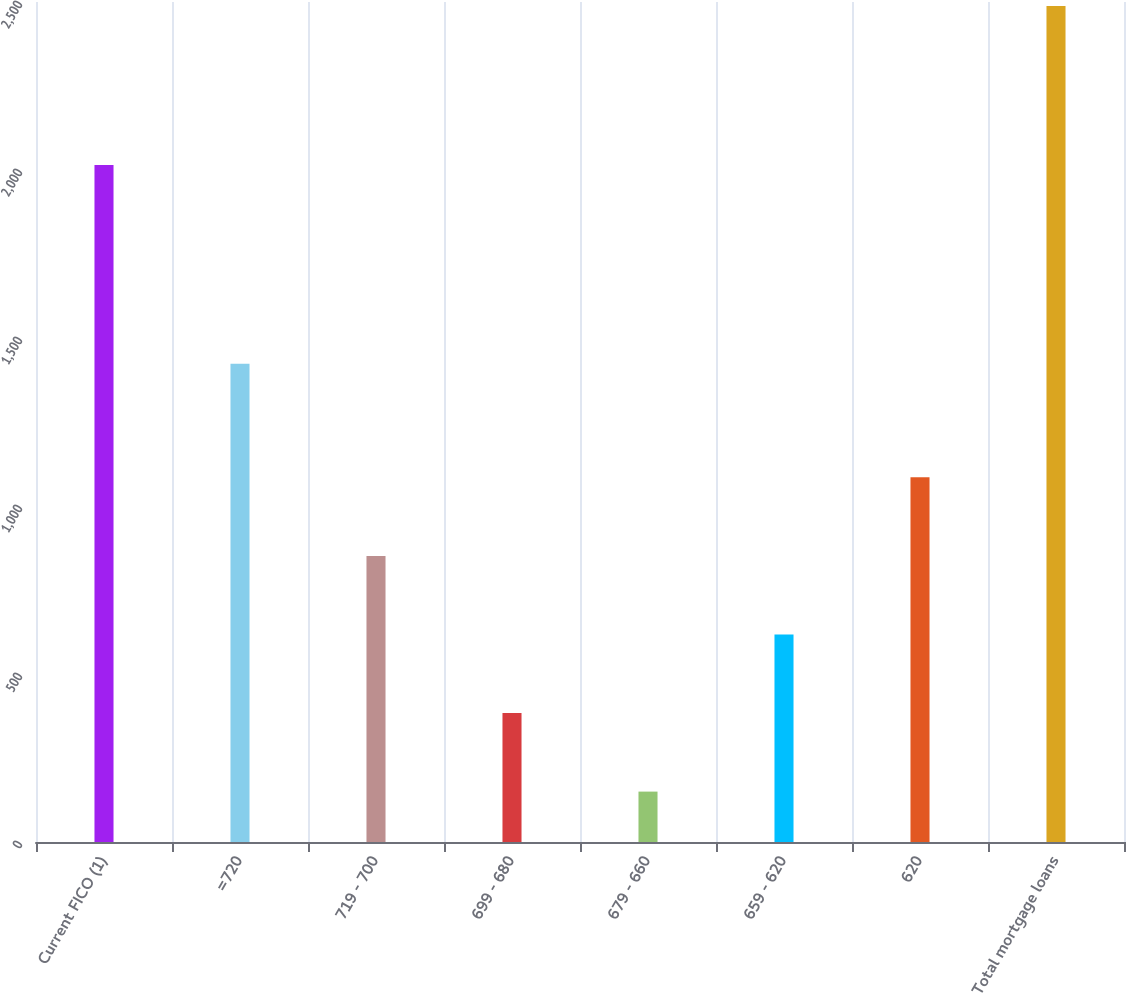Convert chart. <chart><loc_0><loc_0><loc_500><loc_500><bar_chart><fcel>Current FICO (1)<fcel>=720<fcel>719 - 700<fcel>699 - 680<fcel>679 - 660<fcel>659 - 620<fcel>620<fcel>Total mortgage loans<nl><fcel>2015<fcel>1423<fcel>851.4<fcel>383.8<fcel>150<fcel>617.6<fcel>1085.2<fcel>2488<nl></chart> 